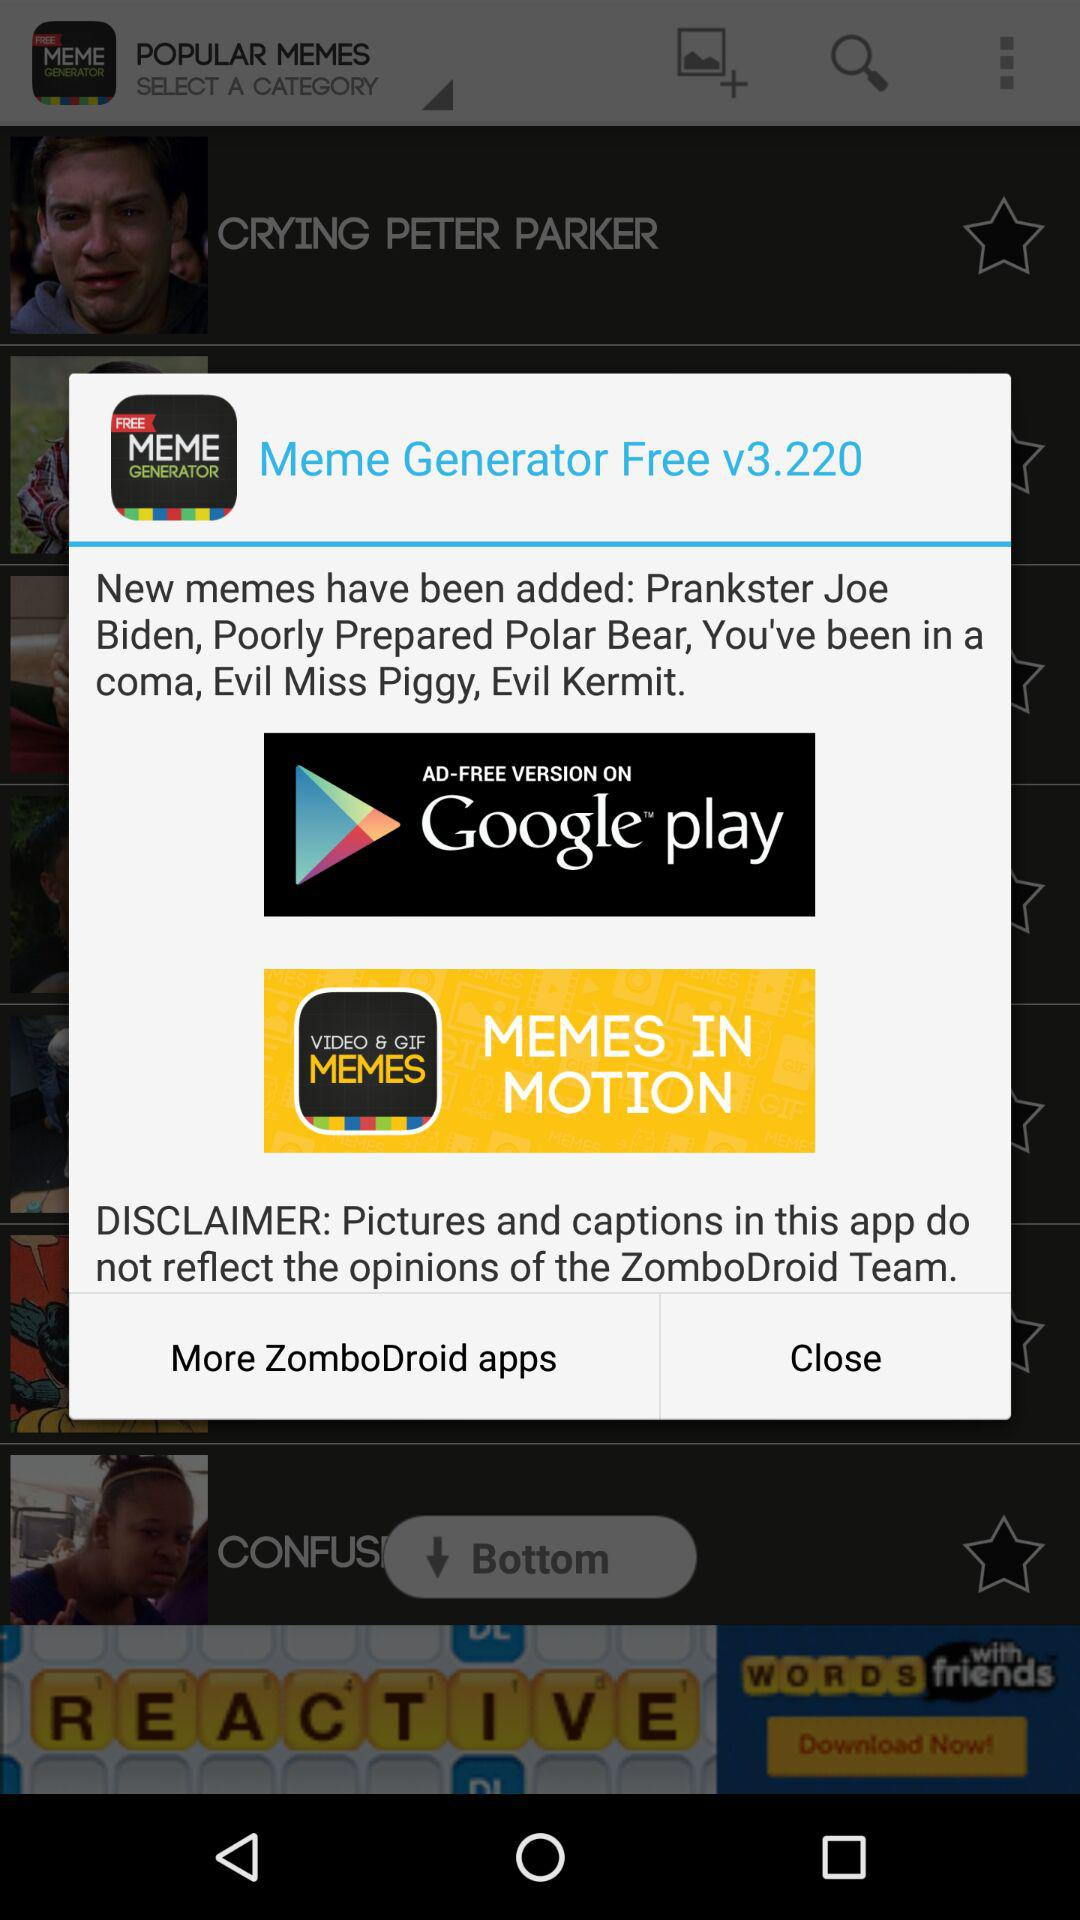How many new memes have been added to the app?
Answer the question using a single word or phrase. 5 